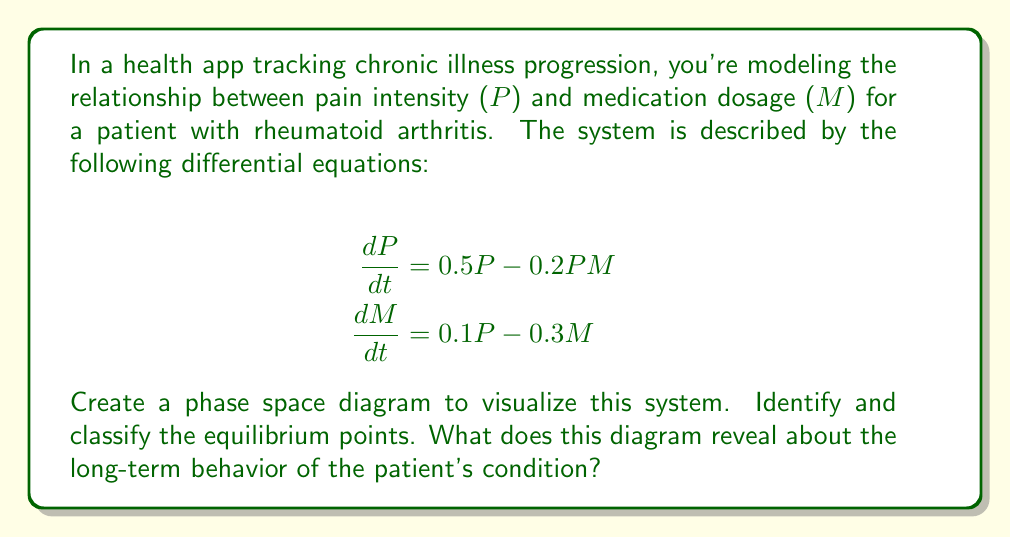Solve this math problem. 1) First, we need to find the equilibrium points by setting both equations to zero:

   $$0.5P - 0.2PM = 0$$
   $$0.1P - 0.3M = 0$$

2) From the second equation: $M = \frac{1}{3}P$

3) Substituting this into the first equation:
   $$0.5P - 0.2P(\frac{1}{3}P) = 0$$
   $$0.5P - \frac{1}{15}P^2 = 0$$
   $$P(0.5 - \frac{1}{15}P) = 0$$

4) Solving this, we get two equilibrium points:
   $(P,M) = (0,0)$ and $(P,M) = (7.5,2.5)$

5) To classify these points, we need to find the Jacobian matrix:

   $$J = \begin{bmatrix}
   0.5 - 0.2M & -0.2P \\
   0.1 & -0.3
   \end{bmatrix}$$

6) At (0,0):
   $$J_{(0,0)} = \begin{bmatrix}
   0.5 & 0 \\
   0.1 & -0.3
   \end{bmatrix}$$
   Eigenvalues: 0.5 and -0.3
   This is a saddle point.

7) At (7.5,2.5):
   $$J_{(7.5,2.5)} = \begin{bmatrix}
   0 & -1.5 \\
   0.1 & -0.3
   \end{bmatrix}$$
   Eigenvalues: $-0.15 \pm 0.39i$
   This is a stable spiral point.

8) The phase space diagram would show:
   - Trajectories moving away from (0,0) in one direction and towards it in another (saddle point behavior)
   - Trajectories spiraling towards (7.5,2.5) (stable spiral behavior)

[asy]
import graph;
size(200);
xaxis("P",Arrow);
yaxis("M",Arrow);

void vector(real x, real y) {
  real dx = 0.5*x - 0.2*x*y;
  real dy = 0.1*x - 0.3*y;
  real l = sqrt(dx^2+dy^2);
  if(l > 0.1) {draw((x,y)--(x+0.5*dx/l,y+0.5*dy/l),Arrow);}
}

for(int i=0; i<10; ++i) {
  for(int j=0; j<10; ++j) {
    vector(i,j);
  }
}

dot((0,0));
dot((7.5,2.5));
label("(0,0)",(0,0),SW);
label("(7.5,2.5)",(7.5,2.5),NE);
[/asy]

9) This diagram reveals that:
   - Without medication (M=0), pain will increase exponentially
   - There's a stable equilibrium at (7.5,2.5), suggesting that with proper medication, pain can be managed at a constant level
   - Most trajectories spiral towards this stable point, indicating that the treatment strategy is effective for various initial conditions
Answer: The phase space diagram shows a saddle point at (0,0) and a stable spiral at (7.5,2.5), indicating that with proper medication, the patient's pain can be managed at a stable level over time. 